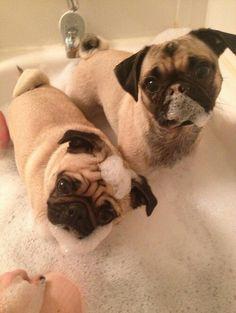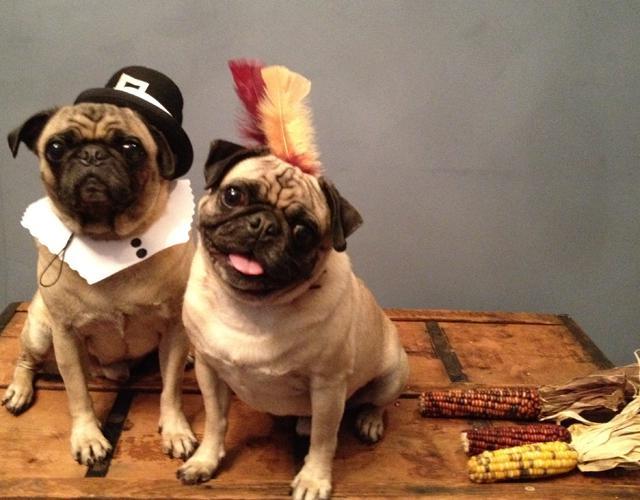The first image is the image on the left, the second image is the image on the right. Evaluate the accuracy of this statement regarding the images: "An image shows two pug dogs side-by-side in a roundish container.". Is it true? Answer yes or no. No. The first image is the image on the left, the second image is the image on the right. Examine the images to the left and right. Is the description "There is no more than one dog in the left image." accurate? Answer yes or no. No. 